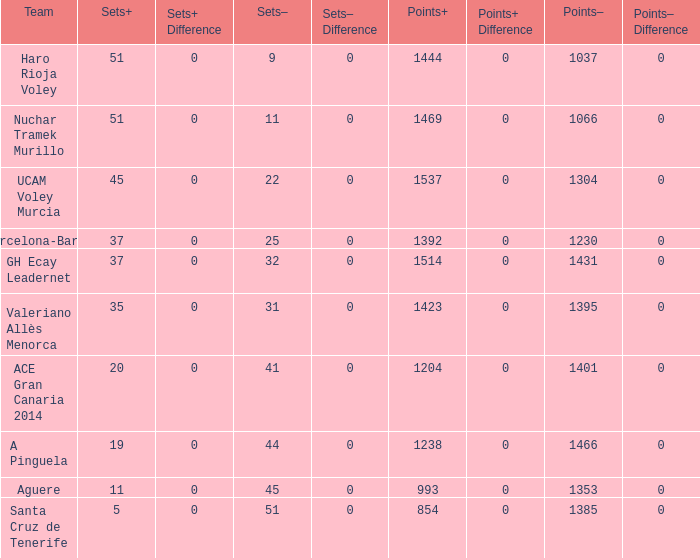Parse the table in full. {'header': ['Team', 'Sets+', 'Sets+ Difference', 'Sets–', 'Sets– Difference', 'Points+', 'Points+ Difference', 'Points–', 'Points– Difference'], 'rows': [['Haro Rioja Voley', '51', '0', '9', '0', '1444', '0', '1037', '0'], ['Nuchar Tramek Murillo', '51', '0', '11', '0', '1469', '0', '1066', '0'], ['UCAM Voley Murcia', '45', '0', '22', '0', '1537', '0', '1304', '0'], ['Barcelona-Barça', '37', '0', '25', '0', '1392', '0', '1230', '0'], ['GH Ecay Leadernet', '37', '0', '32', '0', '1514', '0', '1431', '0'], ['Valeriano Allès Menorca', '35', '0', '31', '0', '1423', '0', '1395', '0'], ['ACE Gran Canaria 2014', '20', '0', '41', '0', '1204', '0', '1401', '0'], ['A Pinguela', '19', '0', '44', '0', '1238', '0', '1466', '0'], ['Aguere', '11', '0', '45', '0', '993', '0', '1353', '0'], ['Santa Cruz de Tenerife', '5', '0', '51', '0', '854', '0', '1385', '0']]} What is the highest Points+ number when the Points- number is larger than 1385, a Sets+ number smaller than 37 and a Sets- number larger than 41? 1238.0. 